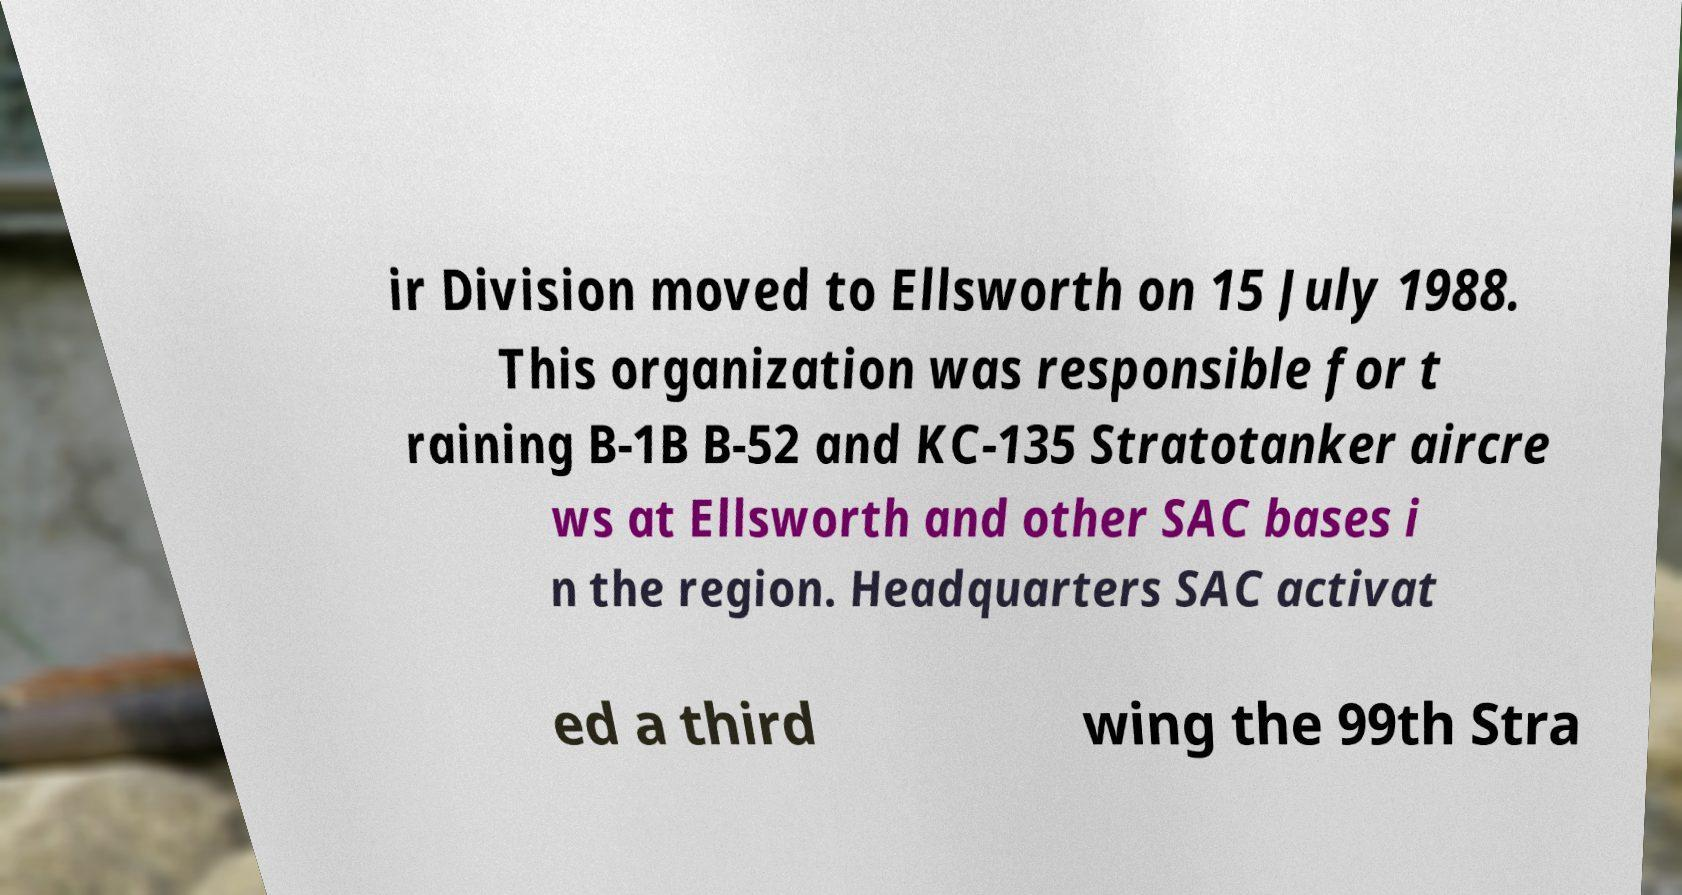I need the written content from this picture converted into text. Can you do that? ir Division moved to Ellsworth on 15 July 1988. This organization was responsible for t raining B-1B B-52 and KC-135 Stratotanker aircre ws at Ellsworth and other SAC bases i n the region. Headquarters SAC activat ed a third wing the 99th Stra 